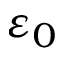Convert formula to latex. <formula><loc_0><loc_0><loc_500><loc_500>\varepsilon _ { 0 }</formula> 